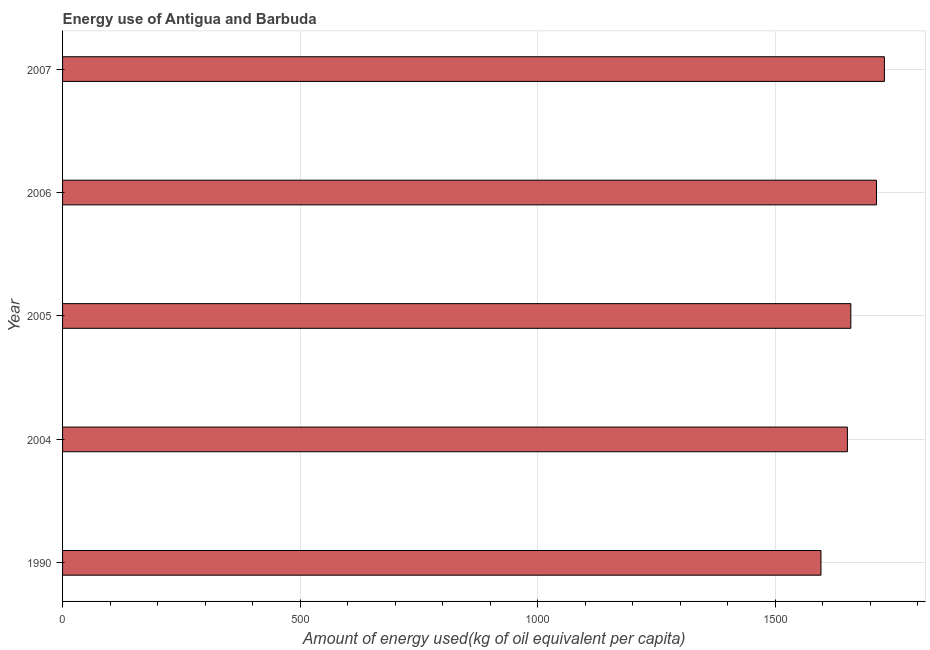What is the title of the graph?
Keep it short and to the point. Energy use of Antigua and Barbuda. What is the label or title of the X-axis?
Your answer should be compact. Amount of energy used(kg of oil equivalent per capita). What is the label or title of the Y-axis?
Your answer should be very brief. Year. What is the amount of energy used in 2007?
Your response must be concise. 1729.92. Across all years, what is the maximum amount of energy used?
Your response must be concise. 1729.92. Across all years, what is the minimum amount of energy used?
Your answer should be compact. 1596.41. What is the sum of the amount of energy used?
Keep it short and to the point. 8350.91. What is the difference between the amount of energy used in 2005 and 2006?
Provide a succinct answer. -53.95. What is the average amount of energy used per year?
Your answer should be compact. 1670.18. What is the median amount of energy used?
Give a very brief answer. 1659.3. In how many years, is the amount of energy used greater than 1000 kg?
Give a very brief answer. 5. Is the difference between the amount of energy used in 1990 and 2005 greater than the difference between any two years?
Your response must be concise. No. What is the difference between the highest and the second highest amount of energy used?
Ensure brevity in your answer.  16.67. Is the sum of the amount of energy used in 2004 and 2006 greater than the maximum amount of energy used across all years?
Offer a terse response. Yes. What is the difference between the highest and the lowest amount of energy used?
Make the answer very short. 133.51. Are all the bars in the graph horizontal?
Provide a short and direct response. Yes. What is the Amount of energy used(kg of oil equivalent per capita) of 1990?
Offer a very short reply. 1596.41. What is the Amount of energy used(kg of oil equivalent per capita) of 2004?
Keep it short and to the point. 1652.02. What is the Amount of energy used(kg of oil equivalent per capita) in 2005?
Ensure brevity in your answer.  1659.3. What is the Amount of energy used(kg of oil equivalent per capita) in 2006?
Your answer should be compact. 1713.25. What is the Amount of energy used(kg of oil equivalent per capita) of 2007?
Offer a terse response. 1729.92. What is the difference between the Amount of energy used(kg of oil equivalent per capita) in 1990 and 2004?
Your answer should be very brief. -55.61. What is the difference between the Amount of energy used(kg of oil equivalent per capita) in 1990 and 2005?
Offer a terse response. -62.89. What is the difference between the Amount of energy used(kg of oil equivalent per capita) in 1990 and 2006?
Your answer should be very brief. -116.84. What is the difference between the Amount of energy used(kg of oil equivalent per capita) in 1990 and 2007?
Offer a very short reply. -133.51. What is the difference between the Amount of energy used(kg of oil equivalent per capita) in 2004 and 2005?
Your answer should be compact. -7.28. What is the difference between the Amount of energy used(kg of oil equivalent per capita) in 2004 and 2006?
Make the answer very short. -61.23. What is the difference between the Amount of energy used(kg of oil equivalent per capita) in 2004 and 2007?
Provide a short and direct response. -77.9. What is the difference between the Amount of energy used(kg of oil equivalent per capita) in 2005 and 2006?
Provide a short and direct response. -53.95. What is the difference between the Amount of energy used(kg of oil equivalent per capita) in 2005 and 2007?
Provide a short and direct response. -70.62. What is the difference between the Amount of energy used(kg of oil equivalent per capita) in 2006 and 2007?
Ensure brevity in your answer.  -16.67. What is the ratio of the Amount of energy used(kg of oil equivalent per capita) in 1990 to that in 2005?
Your response must be concise. 0.96. What is the ratio of the Amount of energy used(kg of oil equivalent per capita) in 1990 to that in 2006?
Provide a succinct answer. 0.93. What is the ratio of the Amount of energy used(kg of oil equivalent per capita) in 1990 to that in 2007?
Your response must be concise. 0.92. What is the ratio of the Amount of energy used(kg of oil equivalent per capita) in 2004 to that in 2005?
Your answer should be very brief. 1. What is the ratio of the Amount of energy used(kg of oil equivalent per capita) in 2004 to that in 2007?
Keep it short and to the point. 0.95. What is the ratio of the Amount of energy used(kg of oil equivalent per capita) in 2005 to that in 2006?
Provide a short and direct response. 0.97. What is the ratio of the Amount of energy used(kg of oil equivalent per capita) in 2005 to that in 2007?
Keep it short and to the point. 0.96. 